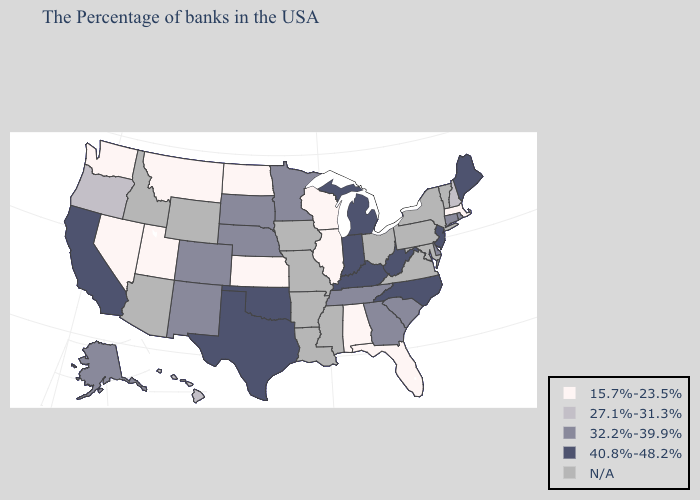Among the states that border Illinois , does Wisconsin have the highest value?
Write a very short answer. No. Does Georgia have the highest value in the USA?
Answer briefly. No. What is the lowest value in the USA?
Quick response, please. 15.7%-23.5%. What is the lowest value in states that border Iowa?
Quick response, please. 15.7%-23.5%. Among the states that border Minnesota , does North Dakota have the lowest value?
Quick response, please. Yes. Among the states that border South Carolina , which have the highest value?
Concise answer only. North Carolina. Does New Jersey have the highest value in the Northeast?
Answer briefly. Yes. What is the value of Iowa?
Answer briefly. N/A. What is the highest value in states that border Kentucky?
Be succinct. 40.8%-48.2%. Does South Dakota have the highest value in the MidWest?
Quick response, please. No. What is the value of New Jersey?
Write a very short answer. 40.8%-48.2%. What is the value of Vermont?
Keep it brief. N/A. Name the states that have a value in the range 40.8%-48.2%?
Keep it brief. Maine, New Jersey, North Carolina, West Virginia, Michigan, Kentucky, Indiana, Oklahoma, Texas, California. Name the states that have a value in the range 15.7%-23.5%?
Keep it brief. Massachusetts, Florida, Alabama, Wisconsin, Illinois, Kansas, North Dakota, Utah, Montana, Nevada, Washington. Which states have the lowest value in the West?
Be succinct. Utah, Montana, Nevada, Washington. 